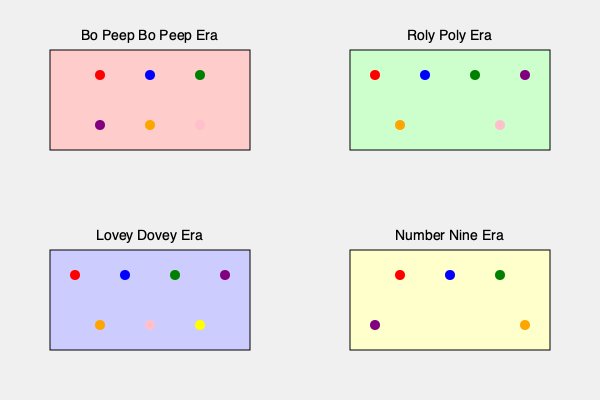Analyze the dance formation patterns of T-ara across different eras as shown in the top-down stage layouts. Which era marks a significant change in the group's formation strategy, and how does it differ from the previous eras in terms of member positioning and overall structure? To answer this question, we need to examine the dance formation patterns across the four eras presented:

1. "Bo Peep Bo Peep" Era:
   - 6 members
   - 2 rows of 3 members each
   - Symmetrical, rectangular formation

2. "Roly Poly" Era:
   - 6 members
   - 4 members in front row, 2 in back
   - Slightly asymmetrical, trapezoidal formation

3. "Lovey Dovey" Era:
   - 7 members
   - 4 members in front row, 3 in back
   - Asymmetrical, wider formation

4. "Number Nine" Era:
   - 5 members
   - 3 members in front row, 2 in back
   - Asymmetrical, arrow-like formation

The significant change in formation strategy occurs in the "Number Nine" era for several reasons:

1. Reduced member count: From 7 in "Lovey Dovey" to 5 in "Number Nine"
2. Unique spacing: Members are positioned farther apart, creating a more spread-out formation
3. Arrow-like structure: The formation resembles an arrow pointing forward, unlike previous rectangular or trapezoidal shapes
4. Emphasis on individuality: The increased space between members allows for more individual spotlight moments

This formation differs from previous eras by:
1. Using fewer members in total
2. Creating a more dynamic and open structure
3. Allowing for more complex choreography due to increased space
4. Potentially highlighting Hahm Eun-Jung's position (assuming she's at the center front)

The "Number Nine" era marks a shift towards a more modern, spacious, and individualistic dance formation strategy compared to the earlier, more compact and uniform formations.
Answer: "Number Nine" era; reduced members, arrow-like formation, increased spacing 